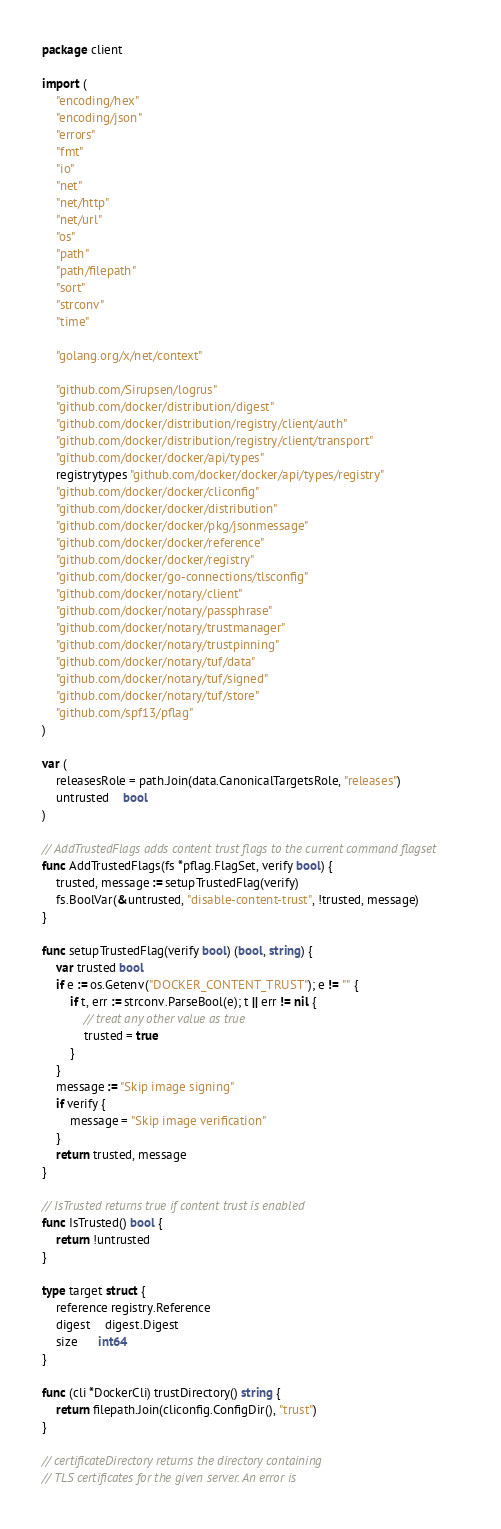<code> <loc_0><loc_0><loc_500><loc_500><_Go_>package client

import (
	"encoding/hex"
	"encoding/json"
	"errors"
	"fmt"
	"io"
	"net"
	"net/http"
	"net/url"
	"os"
	"path"
	"path/filepath"
	"sort"
	"strconv"
	"time"

	"golang.org/x/net/context"

	"github.com/Sirupsen/logrus"
	"github.com/docker/distribution/digest"
	"github.com/docker/distribution/registry/client/auth"
	"github.com/docker/distribution/registry/client/transport"
	"github.com/docker/docker/api/types"
	registrytypes "github.com/docker/docker/api/types/registry"
	"github.com/docker/docker/cliconfig"
	"github.com/docker/docker/distribution"
	"github.com/docker/docker/pkg/jsonmessage"
	"github.com/docker/docker/reference"
	"github.com/docker/docker/registry"
	"github.com/docker/go-connections/tlsconfig"
	"github.com/docker/notary/client"
	"github.com/docker/notary/passphrase"
	"github.com/docker/notary/trustmanager"
	"github.com/docker/notary/trustpinning"
	"github.com/docker/notary/tuf/data"
	"github.com/docker/notary/tuf/signed"
	"github.com/docker/notary/tuf/store"
	"github.com/spf13/pflag"
)

var (
	releasesRole = path.Join(data.CanonicalTargetsRole, "releases")
	untrusted    bool
)

// AddTrustedFlags adds content trust flags to the current command flagset
func AddTrustedFlags(fs *pflag.FlagSet, verify bool) {
	trusted, message := setupTrustedFlag(verify)
	fs.BoolVar(&untrusted, "disable-content-trust", !trusted, message)
}

func setupTrustedFlag(verify bool) (bool, string) {
	var trusted bool
	if e := os.Getenv("DOCKER_CONTENT_TRUST"); e != "" {
		if t, err := strconv.ParseBool(e); t || err != nil {
			// treat any other value as true
			trusted = true
		}
	}
	message := "Skip image signing"
	if verify {
		message = "Skip image verification"
	}
	return trusted, message
}

// IsTrusted returns true if content trust is enabled
func IsTrusted() bool {
	return !untrusted
}

type target struct {
	reference registry.Reference
	digest    digest.Digest
	size      int64
}

func (cli *DockerCli) trustDirectory() string {
	return filepath.Join(cliconfig.ConfigDir(), "trust")
}

// certificateDirectory returns the directory containing
// TLS certificates for the given server. An error is</code> 